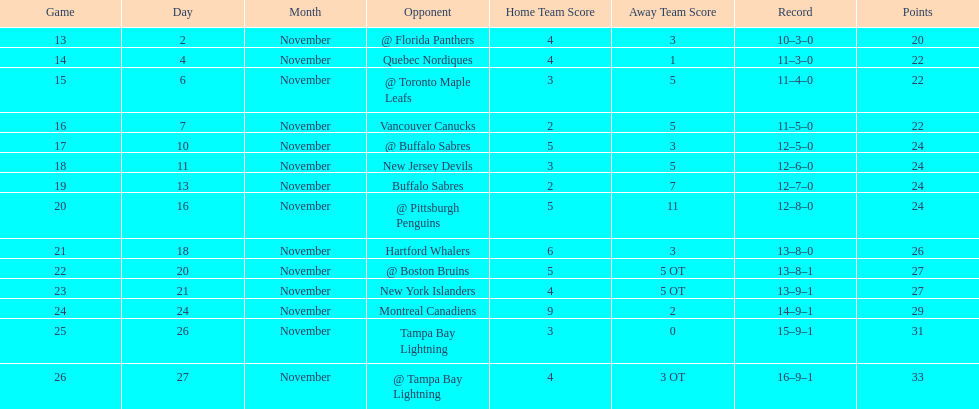What other team had the closest amount of wins? New York Islanders. 